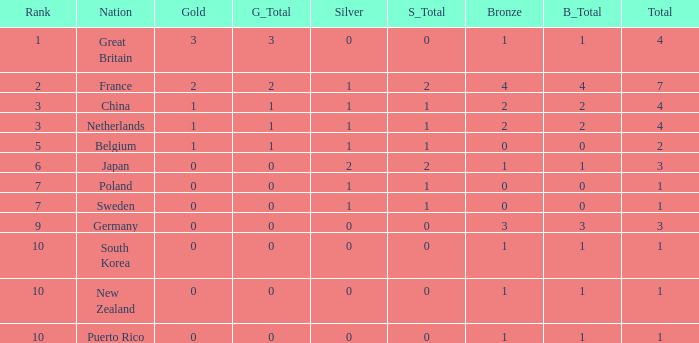What is the total where the gold is larger than 2? 1.0. 